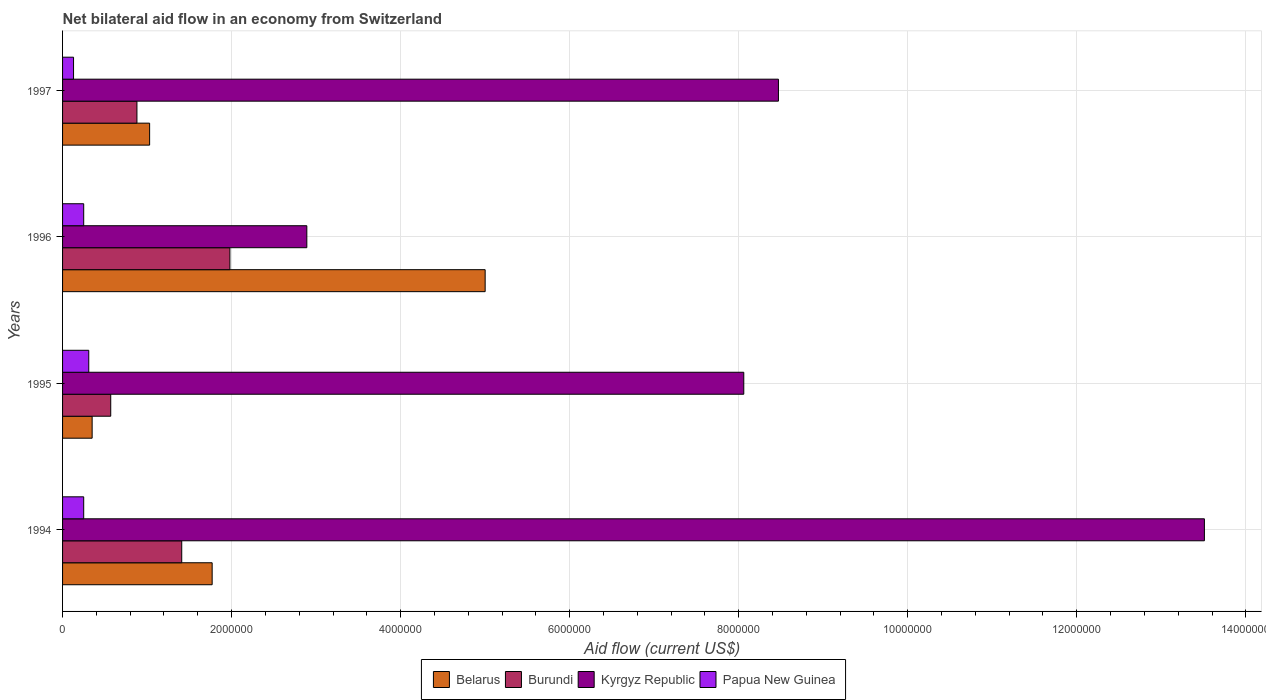How many bars are there on the 3rd tick from the bottom?
Your answer should be very brief. 4. What is the net bilateral aid flow in Burundi in 1996?
Ensure brevity in your answer.  1.98e+06. Across all years, what is the maximum net bilateral aid flow in Belarus?
Provide a succinct answer. 5.00e+06. Across all years, what is the minimum net bilateral aid flow in Burundi?
Give a very brief answer. 5.70e+05. In which year was the net bilateral aid flow in Papua New Guinea maximum?
Offer a very short reply. 1995. What is the total net bilateral aid flow in Papua New Guinea in the graph?
Ensure brevity in your answer.  9.40e+05. What is the difference between the net bilateral aid flow in Papua New Guinea in 1994 and that in 1996?
Your response must be concise. 0. What is the difference between the net bilateral aid flow in Burundi in 1995 and the net bilateral aid flow in Kyrgyz Republic in 1997?
Provide a succinct answer. -7.90e+06. What is the average net bilateral aid flow in Belarus per year?
Keep it short and to the point. 2.04e+06. In the year 1997, what is the difference between the net bilateral aid flow in Burundi and net bilateral aid flow in Kyrgyz Republic?
Offer a very short reply. -7.59e+06. In how many years, is the net bilateral aid flow in Papua New Guinea greater than 4400000 US$?
Make the answer very short. 0. What is the ratio of the net bilateral aid flow in Papua New Guinea in 1996 to that in 1997?
Your answer should be very brief. 1.92. Is the difference between the net bilateral aid flow in Burundi in 1994 and 1995 greater than the difference between the net bilateral aid flow in Kyrgyz Republic in 1994 and 1995?
Your answer should be compact. No. What is the difference between the highest and the second highest net bilateral aid flow in Kyrgyz Republic?
Ensure brevity in your answer.  5.04e+06. What is the difference between the highest and the lowest net bilateral aid flow in Kyrgyz Republic?
Provide a succinct answer. 1.06e+07. In how many years, is the net bilateral aid flow in Kyrgyz Republic greater than the average net bilateral aid flow in Kyrgyz Republic taken over all years?
Provide a succinct answer. 2. Is the sum of the net bilateral aid flow in Papua New Guinea in 1995 and 1997 greater than the maximum net bilateral aid flow in Kyrgyz Republic across all years?
Your response must be concise. No. What does the 2nd bar from the top in 1997 represents?
Your response must be concise. Kyrgyz Republic. What does the 4th bar from the bottom in 1997 represents?
Give a very brief answer. Papua New Guinea. Are all the bars in the graph horizontal?
Keep it short and to the point. Yes. How many years are there in the graph?
Provide a succinct answer. 4. Are the values on the major ticks of X-axis written in scientific E-notation?
Make the answer very short. No. Where does the legend appear in the graph?
Offer a terse response. Bottom center. What is the title of the graph?
Give a very brief answer. Net bilateral aid flow in an economy from Switzerland. What is the Aid flow (current US$) of Belarus in 1994?
Your answer should be very brief. 1.77e+06. What is the Aid flow (current US$) of Burundi in 1994?
Provide a short and direct response. 1.41e+06. What is the Aid flow (current US$) in Kyrgyz Republic in 1994?
Your response must be concise. 1.35e+07. What is the Aid flow (current US$) of Belarus in 1995?
Keep it short and to the point. 3.50e+05. What is the Aid flow (current US$) of Burundi in 1995?
Ensure brevity in your answer.  5.70e+05. What is the Aid flow (current US$) of Kyrgyz Republic in 1995?
Offer a terse response. 8.06e+06. What is the Aid flow (current US$) of Belarus in 1996?
Offer a very short reply. 5.00e+06. What is the Aid flow (current US$) in Burundi in 1996?
Ensure brevity in your answer.  1.98e+06. What is the Aid flow (current US$) in Kyrgyz Republic in 1996?
Provide a short and direct response. 2.89e+06. What is the Aid flow (current US$) of Papua New Guinea in 1996?
Give a very brief answer. 2.50e+05. What is the Aid flow (current US$) in Belarus in 1997?
Your answer should be very brief. 1.03e+06. What is the Aid flow (current US$) in Burundi in 1997?
Ensure brevity in your answer.  8.80e+05. What is the Aid flow (current US$) of Kyrgyz Republic in 1997?
Ensure brevity in your answer.  8.47e+06. What is the Aid flow (current US$) in Papua New Guinea in 1997?
Your answer should be compact. 1.30e+05. Across all years, what is the maximum Aid flow (current US$) of Burundi?
Offer a very short reply. 1.98e+06. Across all years, what is the maximum Aid flow (current US$) of Kyrgyz Republic?
Provide a succinct answer. 1.35e+07. Across all years, what is the maximum Aid flow (current US$) of Papua New Guinea?
Offer a terse response. 3.10e+05. Across all years, what is the minimum Aid flow (current US$) in Belarus?
Give a very brief answer. 3.50e+05. Across all years, what is the minimum Aid flow (current US$) in Burundi?
Your answer should be compact. 5.70e+05. Across all years, what is the minimum Aid flow (current US$) in Kyrgyz Republic?
Your answer should be very brief. 2.89e+06. Across all years, what is the minimum Aid flow (current US$) in Papua New Guinea?
Ensure brevity in your answer.  1.30e+05. What is the total Aid flow (current US$) in Belarus in the graph?
Make the answer very short. 8.15e+06. What is the total Aid flow (current US$) in Burundi in the graph?
Keep it short and to the point. 4.84e+06. What is the total Aid flow (current US$) of Kyrgyz Republic in the graph?
Offer a very short reply. 3.29e+07. What is the total Aid flow (current US$) in Papua New Guinea in the graph?
Give a very brief answer. 9.40e+05. What is the difference between the Aid flow (current US$) in Belarus in 1994 and that in 1995?
Offer a terse response. 1.42e+06. What is the difference between the Aid flow (current US$) of Burundi in 1994 and that in 1995?
Your answer should be compact. 8.40e+05. What is the difference between the Aid flow (current US$) of Kyrgyz Republic in 1994 and that in 1995?
Your answer should be compact. 5.45e+06. What is the difference between the Aid flow (current US$) of Belarus in 1994 and that in 1996?
Provide a short and direct response. -3.23e+06. What is the difference between the Aid flow (current US$) in Burundi in 1994 and that in 1996?
Provide a succinct answer. -5.70e+05. What is the difference between the Aid flow (current US$) in Kyrgyz Republic in 1994 and that in 1996?
Offer a very short reply. 1.06e+07. What is the difference between the Aid flow (current US$) of Belarus in 1994 and that in 1997?
Offer a terse response. 7.40e+05. What is the difference between the Aid flow (current US$) in Burundi in 1994 and that in 1997?
Offer a very short reply. 5.30e+05. What is the difference between the Aid flow (current US$) in Kyrgyz Republic in 1994 and that in 1997?
Offer a very short reply. 5.04e+06. What is the difference between the Aid flow (current US$) in Belarus in 1995 and that in 1996?
Give a very brief answer. -4.65e+06. What is the difference between the Aid flow (current US$) in Burundi in 1995 and that in 1996?
Ensure brevity in your answer.  -1.41e+06. What is the difference between the Aid flow (current US$) of Kyrgyz Republic in 1995 and that in 1996?
Your answer should be compact. 5.17e+06. What is the difference between the Aid flow (current US$) in Belarus in 1995 and that in 1997?
Provide a short and direct response. -6.80e+05. What is the difference between the Aid flow (current US$) in Burundi in 1995 and that in 1997?
Provide a short and direct response. -3.10e+05. What is the difference between the Aid flow (current US$) of Kyrgyz Republic in 1995 and that in 1997?
Your answer should be compact. -4.10e+05. What is the difference between the Aid flow (current US$) of Papua New Guinea in 1995 and that in 1997?
Keep it short and to the point. 1.80e+05. What is the difference between the Aid flow (current US$) of Belarus in 1996 and that in 1997?
Give a very brief answer. 3.97e+06. What is the difference between the Aid flow (current US$) in Burundi in 1996 and that in 1997?
Keep it short and to the point. 1.10e+06. What is the difference between the Aid flow (current US$) of Kyrgyz Republic in 1996 and that in 1997?
Make the answer very short. -5.58e+06. What is the difference between the Aid flow (current US$) in Belarus in 1994 and the Aid flow (current US$) in Burundi in 1995?
Offer a terse response. 1.20e+06. What is the difference between the Aid flow (current US$) in Belarus in 1994 and the Aid flow (current US$) in Kyrgyz Republic in 1995?
Provide a short and direct response. -6.29e+06. What is the difference between the Aid flow (current US$) in Belarus in 1994 and the Aid flow (current US$) in Papua New Guinea in 1995?
Your answer should be very brief. 1.46e+06. What is the difference between the Aid flow (current US$) in Burundi in 1994 and the Aid flow (current US$) in Kyrgyz Republic in 1995?
Provide a succinct answer. -6.65e+06. What is the difference between the Aid flow (current US$) in Burundi in 1994 and the Aid flow (current US$) in Papua New Guinea in 1995?
Your response must be concise. 1.10e+06. What is the difference between the Aid flow (current US$) of Kyrgyz Republic in 1994 and the Aid flow (current US$) of Papua New Guinea in 1995?
Offer a terse response. 1.32e+07. What is the difference between the Aid flow (current US$) in Belarus in 1994 and the Aid flow (current US$) in Burundi in 1996?
Make the answer very short. -2.10e+05. What is the difference between the Aid flow (current US$) of Belarus in 1994 and the Aid flow (current US$) of Kyrgyz Republic in 1996?
Keep it short and to the point. -1.12e+06. What is the difference between the Aid flow (current US$) of Belarus in 1994 and the Aid flow (current US$) of Papua New Guinea in 1996?
Offer a very short reply. 1.52e+06. What is the difference between the Aid flow (current US$) in Burundi in 1994 and the Aid flow (current US$) in Kyrgyz Republic in 1996?
Ensure brevity in your answer.  -1.48e+06. What is the difference between the Aid flow (current US$) of Burundi in 1994 and the Aid flow (current US$) of Papua New Guinea in 1996?
Provide a short and direct response. 1.16e+06. What is the difference between the Aid flow (current US$) of Kyrgyz Republic in 1994 and the Aid flow (current US$) of Papua New Guinea in 1996?
Offer a very short reply. 1.33e+07. What is the difference between the Aid flow (current US$) in Belarus in 1994 and the Aid flow (current US$) in Burundi in 1997?
Offer a terse response. 8.90e+05. What is the difference between the Aid flow (current US$) of Belarus in 1994 and the Aid flow (current US$) of Kyrgyz Republic in 1997?
Offer a terse response. -6.70e+06. What is the difference between the Aid flow (current US$) of Belarus in 1994 and the Aid flow (current US$) of Papua New Guinea in 1997?
Your answer should be compact. 1.64e+06. What is the difference between the Aid flow (current US$) of Burundi in 1994 and the Aid flow (current US$) of Kyrgyz Republic in 1997?
Provide a succinct answer. -7.06e+06. What is the difference between the Aid flow (current US$) in Burundi in 1994 and the Aid flow (current US$) in Papua New Guinea in 1997?
Your response must be concise. 1.28e+06. What is the difference between the Aid flow (current US$) in Kyrgyz Republic in 1994 and the Aid flow (current US$) in Papua New Guinea in 1997?
Your answer should be very brief. 1.34e+07. What is the difference between the Aid flow (current US$) in Belarus in 1995 and the Aid flow (current US$) in Burundi in 1996?
Give a very brief answer. -1.63e+06. What is the difference between the Aid flow (current US$) of Belarus in 1995 and the Aid flow (current US$) of Kyrgyz Republic in 1996?
Your answer should be very brief. -2.54e+06. What is the difference between the Aid flow (current US$) in Belarus in 1995 and the Aid flow (current US$) in Papua New Guinea in 1996?
Your answer should be compact. 1.00e+05. What is the difference between the Aid flow (current US$) of Burundi in 1995 and the Aid flow (current US$) of Kyrgyz Republic in 1996?
Give a very brief answer. -2.32e+06. What is the difference between the Aid flow (current US$) of Kyrgyz Republic in 1995 and the Aid flow (current US$) of Papua New Guinea in 1996?
Give a very brief answer. 7.81e+06. What is the difference between the Aid flow (current US$) of Belarus in 1995 and the Aid flow (current US$) of Burundi in 1997?
Ensure brevity in your answer.  -5.30e+05. What is the difference between the Aid flow (current US$) of Belarus in 1995 and the Aid flow (current US$) of Kyrgyz Republic in 1997?
Provide a short and direct response. -8.12e+06. What is the difference between the Aid flow (current US$) in Burundi in 1995 and the Aid flow (current US$) in Kyrgyz Republic in 1997?
Give a very brief answer. -7.90e+06. What is the difference between the Aid flow (current US$) in Burundi in 1995 and the Aid flow (current US$) in Papua New Guinea in 1997?
Your response must be concise. 4.40e+05. What is the difference between the Aid flow (current US$) in Kyrgyz Republic in 1995 and the Aid flow (current US$) in Papua New Guinea in 1997?
Ensure brevity in your answer.  7.93e+06. What is the difference between the Aid flow (current US$) in Belarus in 1996 and the Aid flow (current US$) in Burundi in 1997?
Make the answer very short. 4.12e+06. What is the difference between the Aid flow (current US$) in Belarus in 1996 and the Aid flow (current US$) in Kyrgyz Republic in 1997?
Your response must be concise. -3.47e+06. What is the difference between the Aid flow (current US$) in Belarus in 1996 and the Aid flow (current US$) in Papua New Guinea in 1997?
Offer a terse response. 4.87e+06. What is the difference between the Aid flow (current US$) in Burundi in 1996 and the Aid flow (current US$) in Kyrgyz Republic in 1997?
Give a very brief answer. -6.49e+06. What is the difference between the Aid flow (current US$) in Burundi in 1996 and the Aid flow (current US$) in Papua New Guinea in 1997?
Give a very brief answer. 1.85e+06. What is the difference between the Aid flow (current US$) of Kyrgyz Republic in 1996 and the Aid flow (current US$) of Papua New Guinea in 1997?
Keep it short and to the point. 2.76e+06. What is the average Aid flow (current US$) of Belarus per year?
Offer a very short reply. 2.04e+06. What is the average Aid flow (current US$) in Burundi per year?
Provide a succinct answer. 1.21e+06. What is the average Aid flow (current US$) of Kyrgyz Republic per year?
Offer a very short reply. 8.23e+06. What is the average Aid flow (current US$) in Papua New Guinea per year?
Offer a very short reply. 2.35e+05. In the year 1994, what is the difference between the Aid flow (current US$) of Belarus and Aid flow (current US$) of Burundi?
Make the answer very short. 3.60e+05. In the year 1994, what is the difference between the Aid flow (current US$) of Belarus and Aid flow (current US$) of Kyrgyz Republic?
Offer a terse response. -1.17e+07. In the year 1994, what is the difference between the Aid flow (current US$) of Belarus and Aid flow (current US$) of Papua New Guinea?
Offer a very short reply. 1.52e+06. In the year 1994, what is the difference between the Aid flow (current US$) in Burundi and Aid flow (current US$) in Kyrgyz Republic?
Provide a succinct answer. -1.21e+07. In the year 1994, what is the difference between the Aid flow (current US$) in Burundi and Aid flow (current US$) in Papua New Guinea?
Your answer should be compact. 1.16e+06. In the year 1994, what is the difference between the Aid flow (current US$) in Kyrgyz Republic and Aid flow (current US$) in Papua New Guinea?
Keep it short and to the point. 1.33e+07. In the year 1995, what is the difference between the Aid flow (current US$) in Belarus and Aid flow (current US$) in Burundi?
Your answer should be very brief. -2.20e+05. In the year 1995, what is the difference between the Aid flow (current US$) of Belarus and Aid flow (current US$) of Kyrgyz Republic?
Your answer should be very brief. -7.71e+06. In the year 1995, what is the difference between the Aid flow (current US$) in Burundi and Aid flow (current US$) in Kyrgyz Republic?
Your answer should be compact. -7.49e+06. In the year 1995, what is the difference between the Aid flow (current US$) in Kyrgyz Republic and Aid flow (current US$) in Papua New Guinea?
Provide a succinct answer. 7.75e+06. In the year 1996, what is the difference between the Aid flow (current US$) in Belarus and Aid flow (current US$) in Burundi?
Offer a terse response. 3.02e+06. In the year 1996, what is the difference between the Aid flow (current US$) in Belarus and Aid flow (current US$) in Kyrgyz Republic?
Provide a succinct answer. 2.11e+06. In the year 1996, what is the difference between the Aid flow (current US$) of Belarus and Aid flow (current US$) of Papua New Guinea?
Your response must be concise. 4.75e+06. In the year 1996, what is the difference between the Aid flow (current US$) in Burundi and Aid flow (current US$) in Kyrgyz Republic?
Offer a very short reply. -9.10e+05. In the year 1996, what is the difference between the Aid flow (current US$) in Burundi and Aid flow (current US$) in Papua New Guinea?
Keep it short and to the point. 1.73e+06. In the year 1996, what is the difference between the Aid flow (current US$) in Kyrgyz Republic and Aid flow (current US$) in Papua New Guinea?
Your answer should be very brief. 2.64e+06. In the year 1997, what is the difference between the Aid flow (current US$) in Belarus and Aid flow (current US$) in Burundi?
Your answer should be compact. 1.50e+05. In the year 1997, what is the difference between the Aid flow (current US$) in Belarus and Aid flow (current US$) in Kyrgyz Republic?
Provide a short and direct response. -7.44e+06. In the year 1997, what is the difference between the Aid flow (current US$) of Belarus and Aid flow (current US$) of Papua New Guinea?
Your response must be concise. 9.00e+05. In the year 1997, what is the difference between the Aid flow (current US$) of Burundi and Aid flow (current US$) of Kyrgyz Republic?
Provide a short and direct response. -7.59e+06. In the year 1997, what is the difference between the Aid flow (current US$) in Burundi and Aid flow (current US$) in Papua New Guinea?
Give a very brief answer. 7.50e+05. In the year 1997, what is the difference between the Aid flow (current US$) in Kyrgyz Republic and Aid flow (current US$) in Papua New Guinea?
Keep it short and to the point. 8.34e+06. What is the ratio of the Aid flow (current US$) of Belarus in 1994 to that in 1995?
Make the answer very short. 5.06. What is the ratio of the Aid flow (current US$) of Burundi in 1994 to that in 1995?
Your response must be concise. 2.47. What is the ratio of the Aid flow (current US$) in Kyrgyz Republic in 1994 to that in 1995?
Make the answer very short. 1.68. What is the ratio of the Aid flow (current US$) of Papua New Guinea in 1994 to that in 1995?
Ensure brevity in your answer.  0.81. What is the ratio of the Aid flow (current US$) in Belarus in 1994 to that in 1996?
Ensure brevity in your answer.  0.35. What is the ratio of the Aid flow (current US$) in Burundi in 1994 to that in 1996?
Your answer should be compact. 0.71. What is the ratio of the Aid flow (current US$) of Kyrgyz Republic in 1994 to that in 1996?
Give a very brief answer. 4.67. What is the ratio of the Aid flow (current US$) in Belarus in 1994 to that in 1997?
Your answer should be very brief. 1.72. What is the ratio of the Aid flow (current US$) in Burundi in 1994 to that in 1997?
Provide a succinct answer. 1.6. What is the ratio of the Aid flow (current US$) in Kyrgyz Republic in 1994 to that in 1997?
Your response must be concise. 1.59. What is the ratio of the Aid flow (current US$) in Papua New Guinea in 1994 to that in 1997?
Offer a very short reply. 1.92. What is the ratio of the Aid flow (current US$) of Belarus in 1995 to that in 1996?
Keep it short and to the point. 0.07. What is the ratio of the Aid flow (current US$) of Burundi in 1995 to that in 1996?
Provide a short and direct response. 0.29. What is the ratio of the Aid flow (current US$) of Kyrgyz Republic in 1995 to that in 1996?
Ensure brevity in your answer.  2.79. What is the ratio of the Aid flow (current US$) of Papua New Guinea in 1995 to that in 1996?
Offer a very short reply. 1.24. What is the ratio of the Aid flow (current US$) in Belarus in 1995 to that in 1997?
Give a very brief answer. 0.34. What is the ratio of the Aid flow (current US$) of Burundi in 1995 to that in 1997?
Keep it short and to the point. 0.65. What is the ratio of the Aid flow (current US$) of Kyrgyz Republic in 1995 to that in 1997?
Keep it short and to the point. 0.95. What is the ratio of the Aid flow (current US$) of Papua New Guinea in 1995 to that in 1997?
Give a very brief answer. 2.38. What is the ratio of the Aid flow (current US$) in Belarus in 1996 to that in 1997?
Provide a short and direct response. 4.85. What is the ratio of the Aid flow (current US$) in Burundi in 1996 to that in 1997?
Offer a very short reply. 2.25. What is the ratio of the Aid flow (current US$) of Kyrgyz Republic in 1996 to that in 1997?
Your response must be concise. 0.34. What is the ratio of the Aid flow (current US$) in Papua New Guinea in 1996 to that in 1997?
Give a very brief answer. 1.92. What is the difference between the highest and the second highest Aid flow (current US$) in Belarus?
Your answer should be very brief. 3.23e+06. What is the difference between the highest and the second highest Aid flow (current US$) of Burundi?
Your answer should be very brief. 5.70e+05. What is the difference between the highest and the second highest Aid flow (current US$) of Kyrgyz Republic?
Offer a very short reply. 5.04e+06. What is the difference between the highest and the second highest Aid flow (current US$) in Papua New Guinea?
Keep it short and to the point. 6.00e+04. What is the difference between the highest and the lowest Aid flow (current US$) of Belarus?
Ensure brevity in your answer.  4.65e+06. What is the difference between the highest and the lowest Aid flow (current US$) in Burundi?
Keep it short and to the point. 1.41e+06. What is the difference between the highest and the lowest Aid flow (current US$) in Kyrgyz Republic?
Your answer should be very brief. 1.06e+07. What is the difference between the highest and the lowest Aid flow (current US$) of Papua New Guinea?
Give a very brief answer. 1.80e+05. 